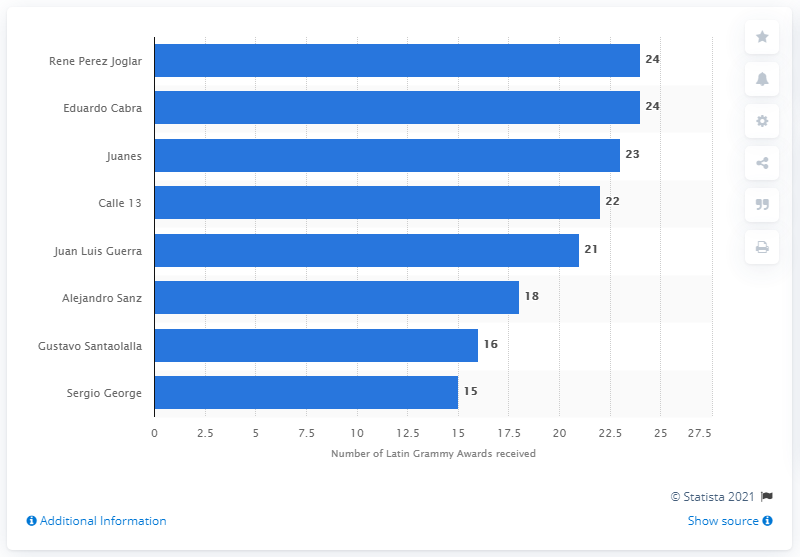Highlight a few significant elements in this photo. Rene Perez Joglar has won a total of 24 Grammy Awards. Rene Perez Joglar, also known as Residente, is a renowned musician and performer. 